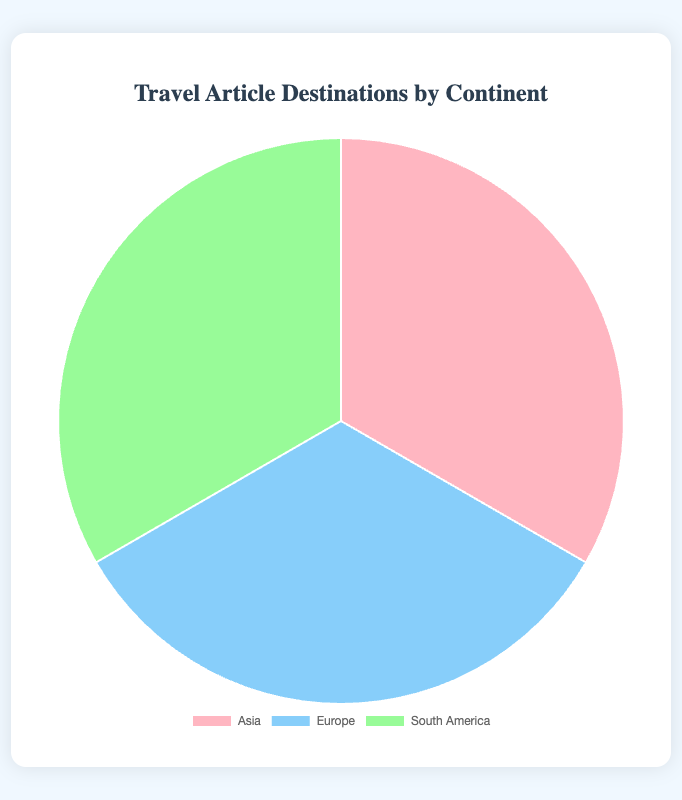What proportion of articles feature destinations in Asia? The segments are 'Asia', 'Europe', and 'South America' with 100% each. Since Asia is one of these continents, Asia has 100%.
Answer: 100% What is the overall proportion of articles featuring destinations in South America compared to Europe? Both South America and Europe segments are 100%, so the overall proportion is equal.
Answer: Equal Which continent had more travel articles featured, Asia or Europe? The pie chart indicates both Asia and Europe segments as 100%.
Answer: Equal If the total number of articles is considered 300, how many articles featured destinations in South America? Each continent is 100%, representing an equal share of 100 articles. For South America, it would be 100 articles.
Answer: 100 articles What is the combined number of articles featured in Europe and South America? Since both Europe and South America segments show 100% each, combined is 100 + 100.
Answer: 200 articles Which continent's travel destinations are represented by the sky blue color in the chart? Sky blue is indicated for Europe destinations in the pie chart.
Answer: Europe If 'Asia' articles need to be divided equally among three countries mentioned, how many articles does each country get? Asia has 100 articles, divided by 3 countries: 100 / 3 ≈ 33.33 articles per country.
Answer: 33.33 articles per country Are South America travel articles represented by a visually larger or smaller segment compared to other continents? Each segment for South America, Europe, and Asia looks equal; thus, they're visually the same size.
Answer: Same size How much is the difference in the number of articles featured between destinations in Asia and Europe? Both Asia and Europe segments are 100%, meaning there's no difference in the number.
Answer: 0 articles If the number of articles for 'Europe' was to represent 140 articles instead, what would be the new proportion per continent? Total articles = 100 (Asia) + 140 (Europe) + 100 (South America) = 340.
Asia: (100/340) ≈ 29.41%
Europe: (140/340) ≈ 41.18%
South America: (100/340) ≈ 29.41%.
Answer: Asia: 29.41%, Europe: 41.18%, South America: 29.41% 